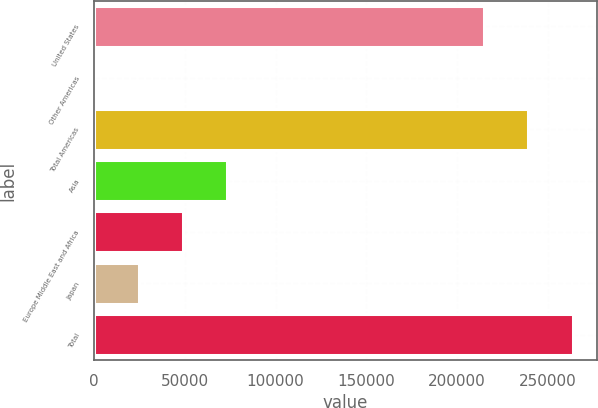<chart> <loc_0><loc_0><loc_500><loc_500><bar_chart><fcel>United States<fcel>Other Americas<fcel>Total Americas<fcel>Asia<fcel>Europe Middle East and Africa<fcel>Japan<fcel>Total<nl><fcel>214711<fcel>185<fcel>239136<fcel>73461.2<fcel>49035.8<fcel>24610.4<fcel>263562<nl></chart> 